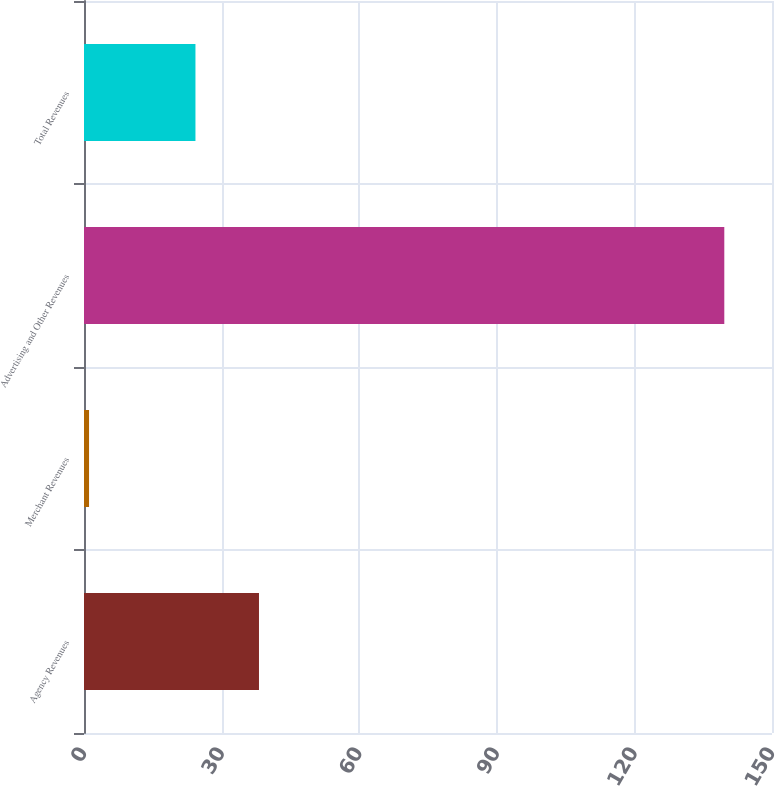<chart> <loc_0><loc_0><loc_500><loc_500><bar_chart><fcel>Agency Revenues<fcel>Merchant Revenues<fcel>Advertising and Other Revenues<fcel>Total Revenues<nl><fcel>38.15<fcel>1.1<fcel>139.6<fcel>24.3<nl></chart> 